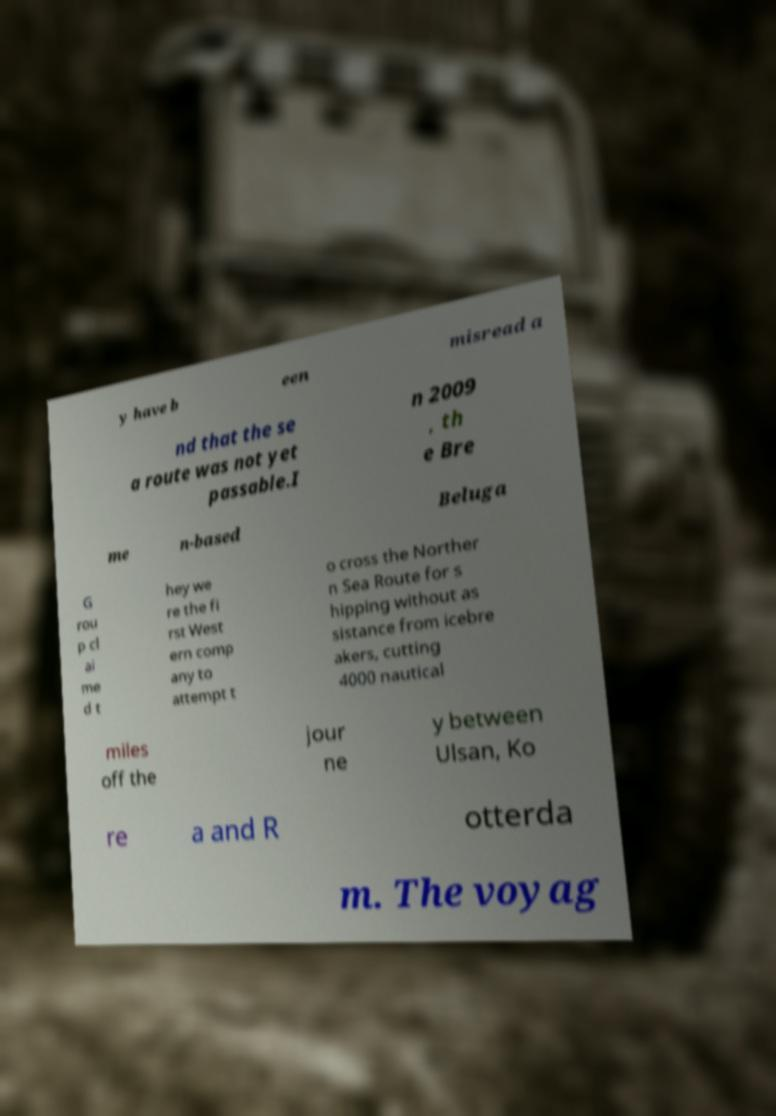There's text embedded in this image that I need extracted. Can you transcribe it verbatim? y have b een misread a nd that the se a route was not yet passable.I n 2009 , th e Bre me n-based Beluga G rou p cl ai me d t hey we re the fi rst West ern comp any to attempt t o cross the Norther n Sea Route for s hipping without as sistance from icebre akers, cutting 4000 nautical miles off the jour ne y between Ulsan, Ko re a and R otterda m. The voyag 